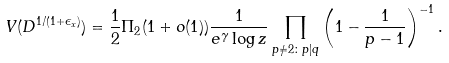Convert formula to latex. <formula><loc_0><loc_0><loc_500><loc_500>V ( D ^ { 1 / ( 1 + \epsilon _ { x } ) } ) = \frac { 1 } { 2 } \Pi _ { 2 } ( 1 + o ( 1 ) ) \frac { 1 } { e ^ { \gamma } \log z } \prod _ { p \not = 2 \colon p | q } \left ( 1 - \frac { 1 } { p - 1 } \right ) ^ { - 1 } .</formula> 